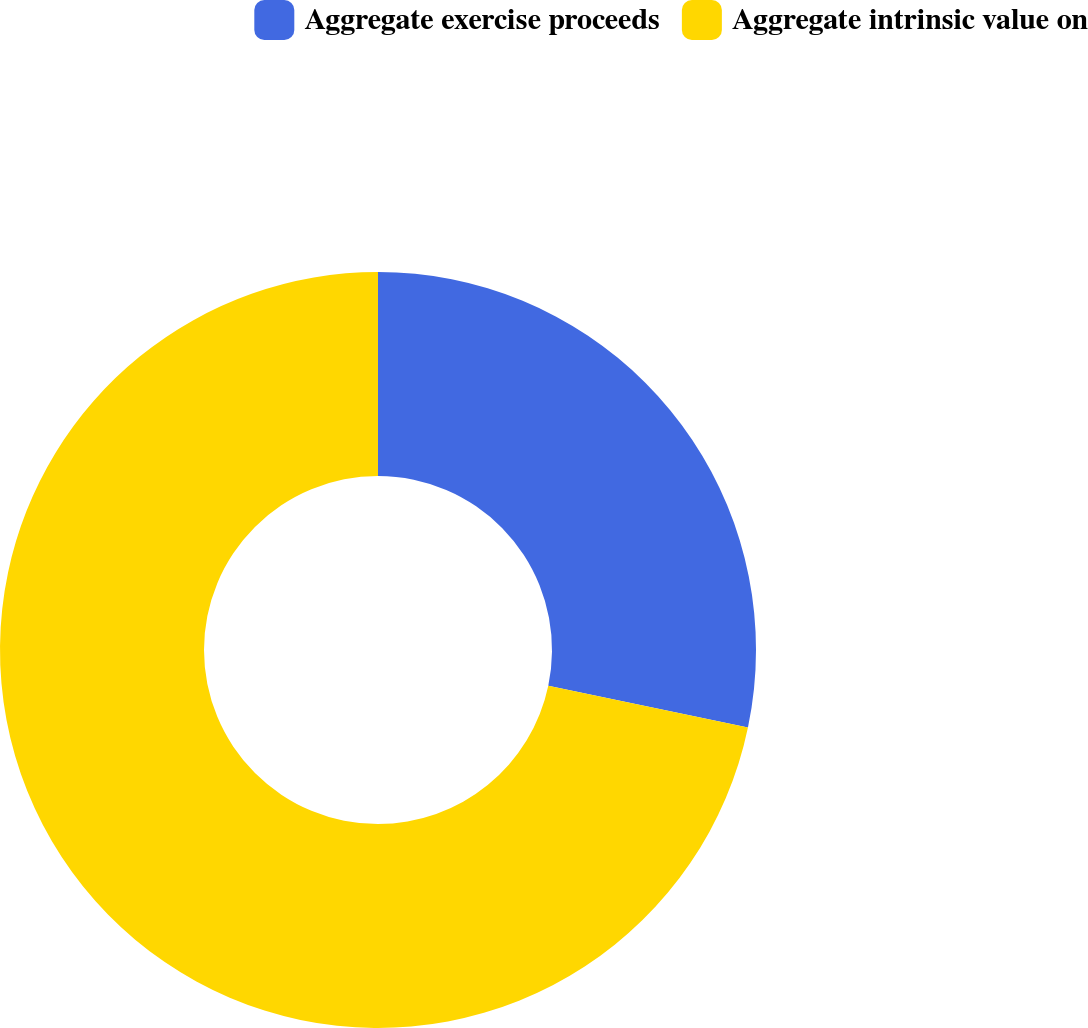Convert chart to OTSL. <chart><loc_0><loc_0><loc_500><loc_500><pie_chart><fcel>Aggregate exercise proceeds<fcel>Aggregate intrinsic value on<nl><fcel>28.29%<fcel>71.71%<nl></chart> 